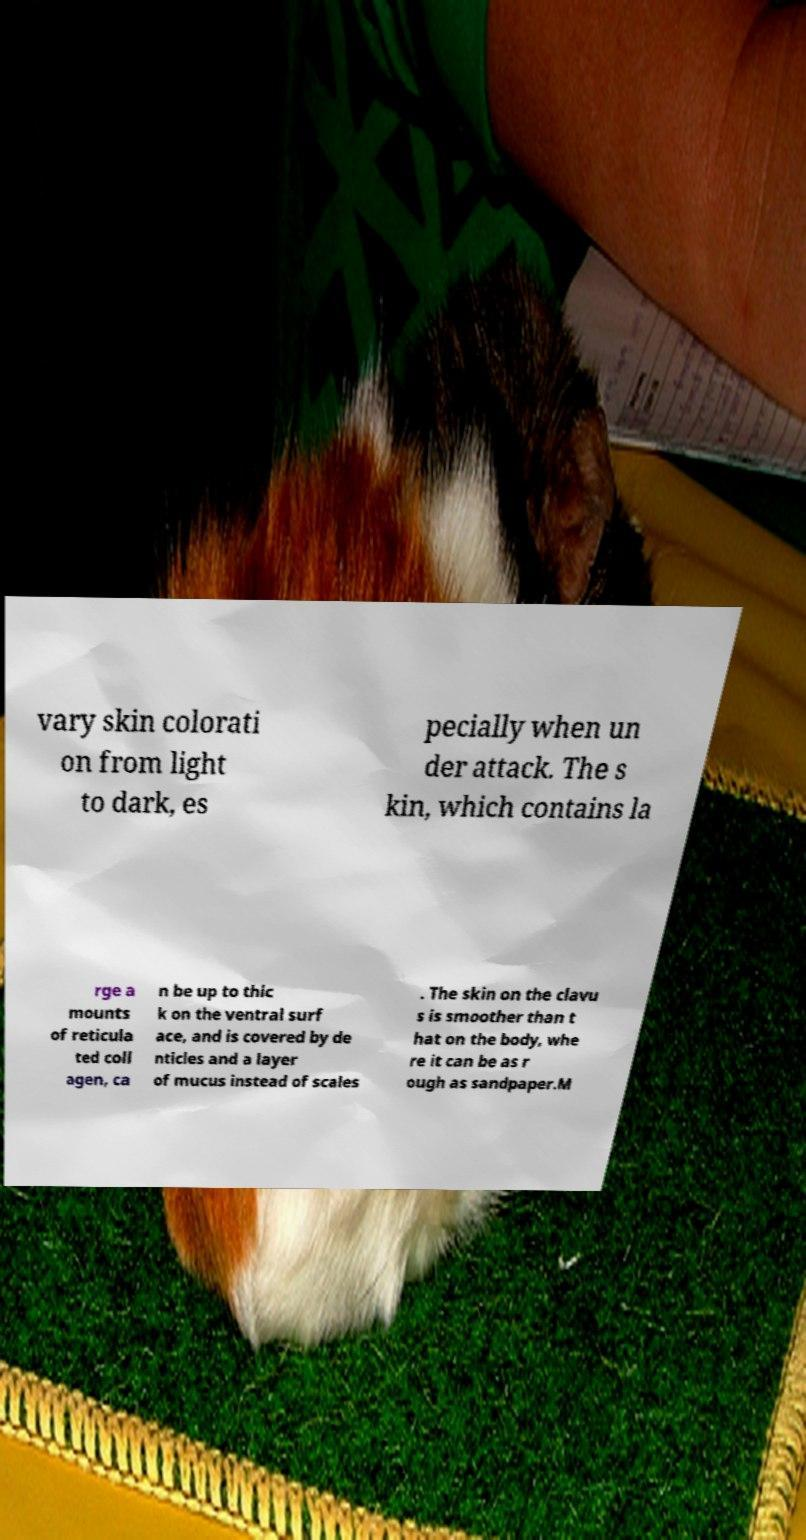I need the written content from this picture converted into text. Can you do that? vary skin colorati on from light to dark, es pecially when un der attack. The s kin, which contains la rge a mounts of reticula ted coll agen, ca n be up to thic k on the ventral surf ace, and is covered by de nticles and a layer of mucus instead of scales . The skin on the clavu s is smoother than t hat on the body, whe re it can be as r ough as sandpaper.M 